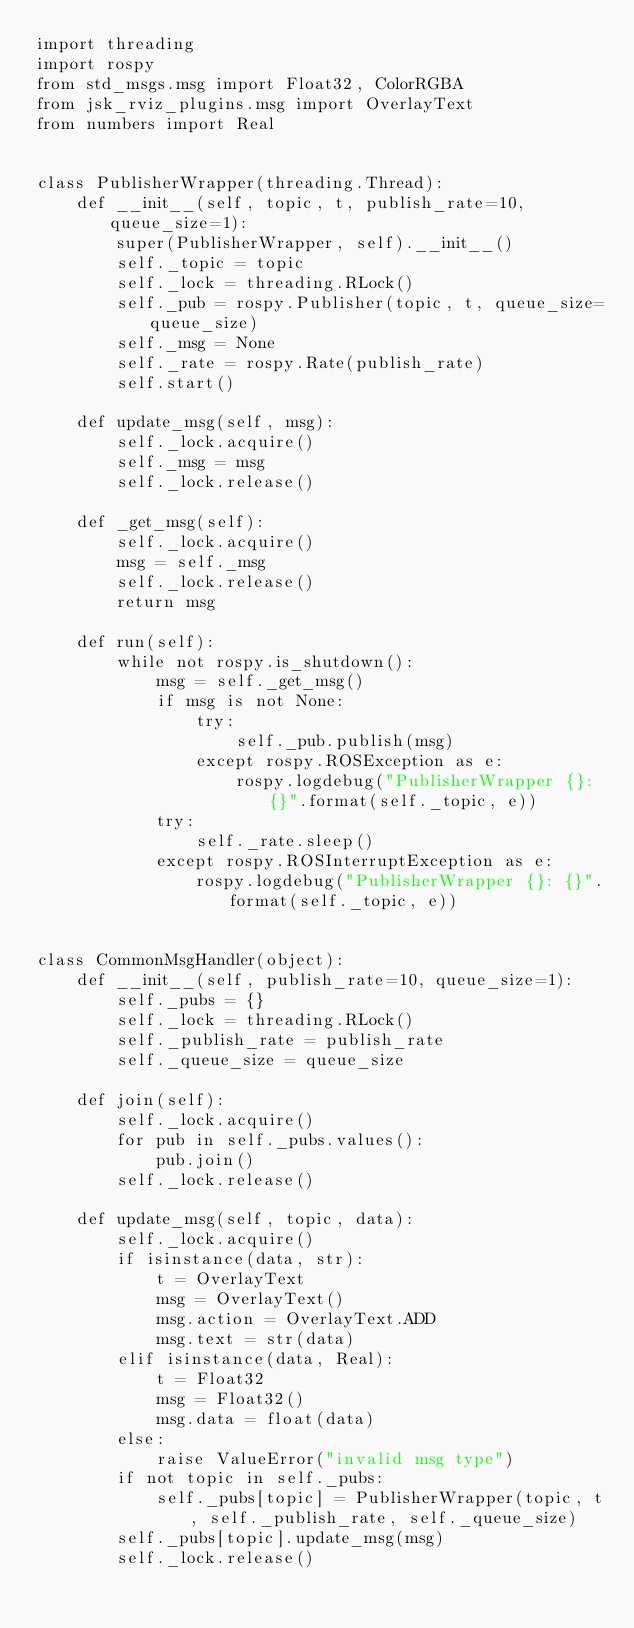Convert code to text. <code><loc_0><loc_0><loc_500><loc_500><_Python_>import threading
import rospy
from std_msgs.msg import Float32, ColorRGBA
from jsk_rviz_plugins.msg import OverlayText
from numbers import Real


class PublisherWrapper(threading.Thread):
    def __init__(self, topic, t, publish_rate=10, queue_size=1):
        super(PublisherWrapper, self).__init__()
        self._topic = topic
        self._lock = threading.RLock()
        self._pub = rospy.Publisher(topic, t, queue_size=queue_size)
        self._msg = None
        self._rate = rospy.Rate(publish_rate)
        self.start()

    def update_msg(self, msg):
        self._lock.acquire()
        self._msg = msg
        self._lock.release()

    def _get_msg(self):
        self._lock.acquire()
        msg = self._msg
        self._lock.release()
        return msg

    def run(self):
        while not rospy.is_shutdown():
            msg = self._get_msg()
            if msg is not None:
                try:
                    self._pub.publish(msg)
                except rospy.ROSException as e:
                    rospy.logdebug("PublisherWrapper {}: {}".format(self._topic, e))
            try:
                self._rate.sleep()
            except rospy.ROSInterruptException as e:
                rospy.logdebug("PublisherWrapper {}: {}".format(self._topic, e))


class CommonMsgHandler(object):
    def __init__(self, publish_rate=10, queue_size=1):
        self._pubs = {}
        self._lock = threading.RLock()
        self._publish_rate = publish_rate
        self._queue_size = queue_size

    def join(self):
        self._lock.acquire()
        for pub in self._pubs.values():
            pub.join()
        self._lock.release()

    def update_msg(self, topic, data):
        self._lock.acquire()
        if isinstance(data, str):
            t = OverlayText
            msg = OverlayText()
            msg.action = OverlayText.ADD
            msg.text = str(data)
        elif isinstance(data, Real):
            t = Float32
            msg = Float32()
            msg.data = float(data)
        else:
            raise ValueError("invalid msg type")
        if not topic in self._pubs:
            self._pubs[topic] = PublisherWrapper(topic, t, self._publish_rate, self._queue_size)
        self._pubs[topic].update_msg(msg)
        self._lock.release()

</code> 